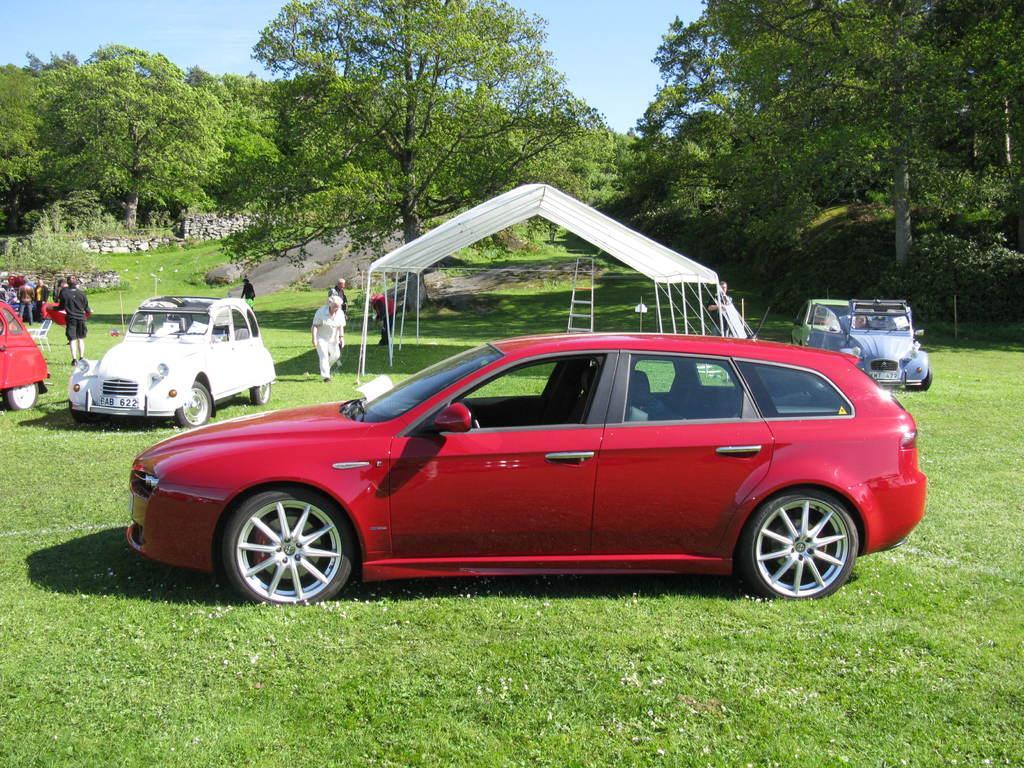Please provide a concise description of this image. In this image I see few cars and I see few people and I see the green grass. In the background I see the trees, plants, stones over here and the blue sky. 